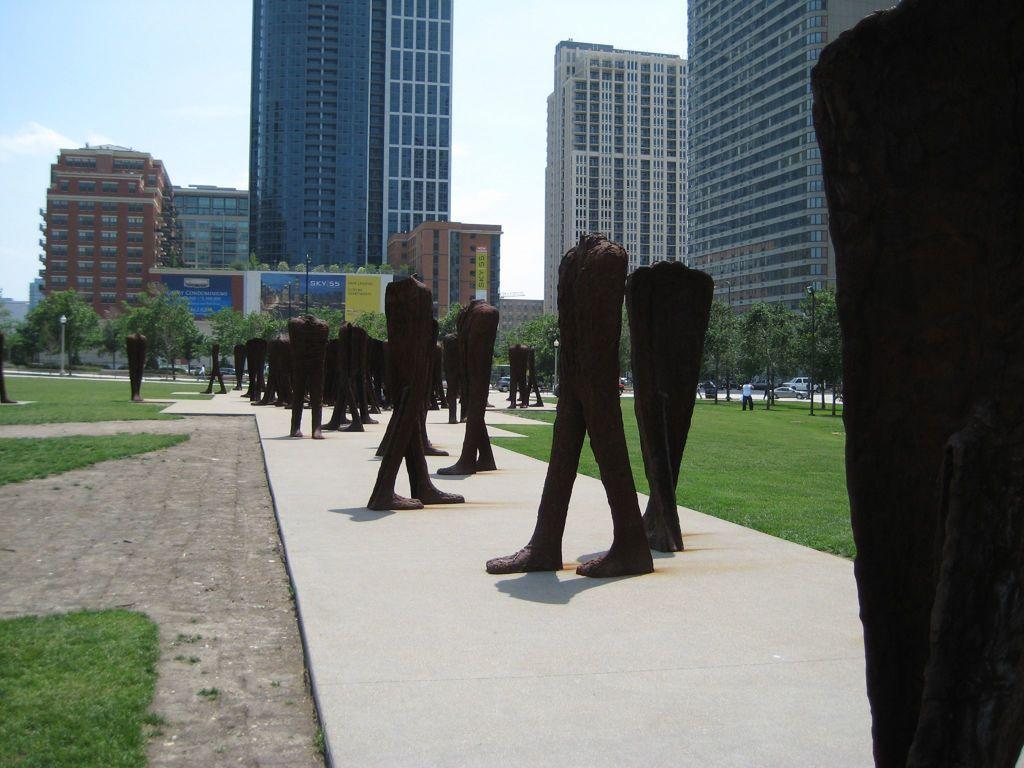Can you describe this image briefly? In the picture we can see a pathway and on it we can see a sculpture of shirt and pants and both the sides of the path we can see the grass surfaces and far away from it, we can see trees and some tower buildings with many floors and behind it we can see the sky with clouds. 